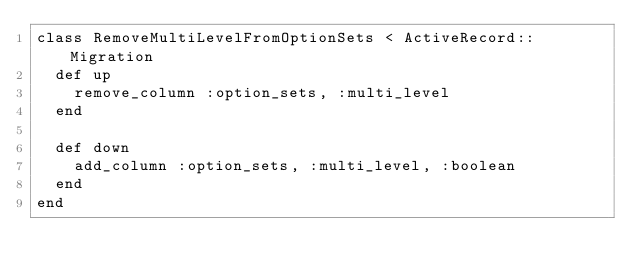<code> <loc_0><loc_0><loc_500><loc_500><_Ruby_>class RemoveMultiLevelFromOptionSets < ActiveRecord::Migration
  def up
    remove_column :option_sets, :multi_level
  end

  def down
    add_column :option_sets, :multi_level, :boolean
  end
end
</code> 